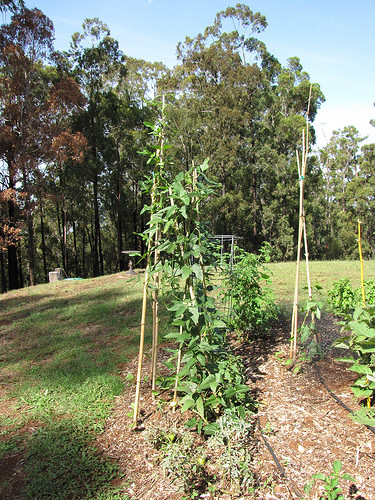<image>
Can you confirm if the plant is in the garden? Yes. The plant is contained within or inside the garden, showing a containment relationship. 